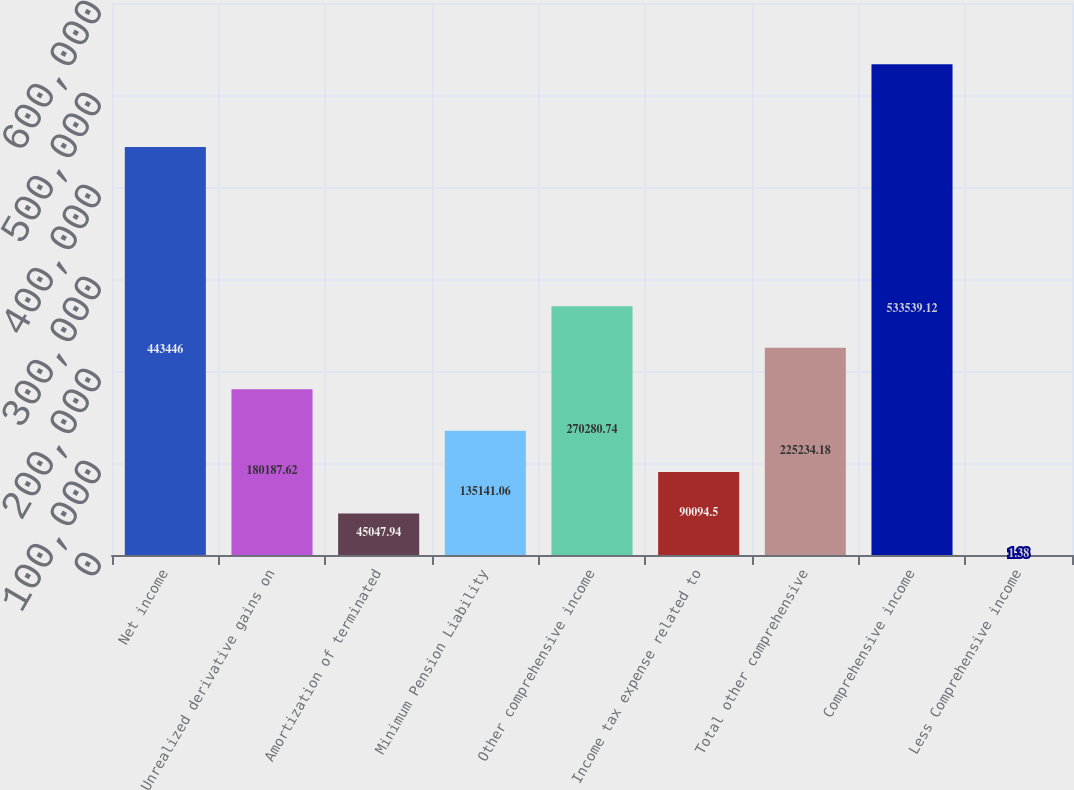<chart> <loc_0><loc_0><loc_500><loc_500><bar_chart><fcel>Net income<fcel>Unrealized derivative gains on<fcel>Amortization of terminated<fcel>Minimum Pension Liability<fcel>Other comprehensive income<fcel>Income tax expense related to<fcel>Total other comprehensive<fcel>Comprehensive income<fcel>Less Comprehensive income<nl><fcel>443446<fcel>180188<fcel>45047.9<fcel>135141<fcel>270281<fcel>90094.5<fcel>225234<fcel>533539<fcel>1.38<nl></chart> 